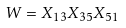<formula> <loc_0><loc_0><loc_500><loc_500>W = X _ { 1 3 } X _ { 3 5 } X _ { 5 1 }</formula> 